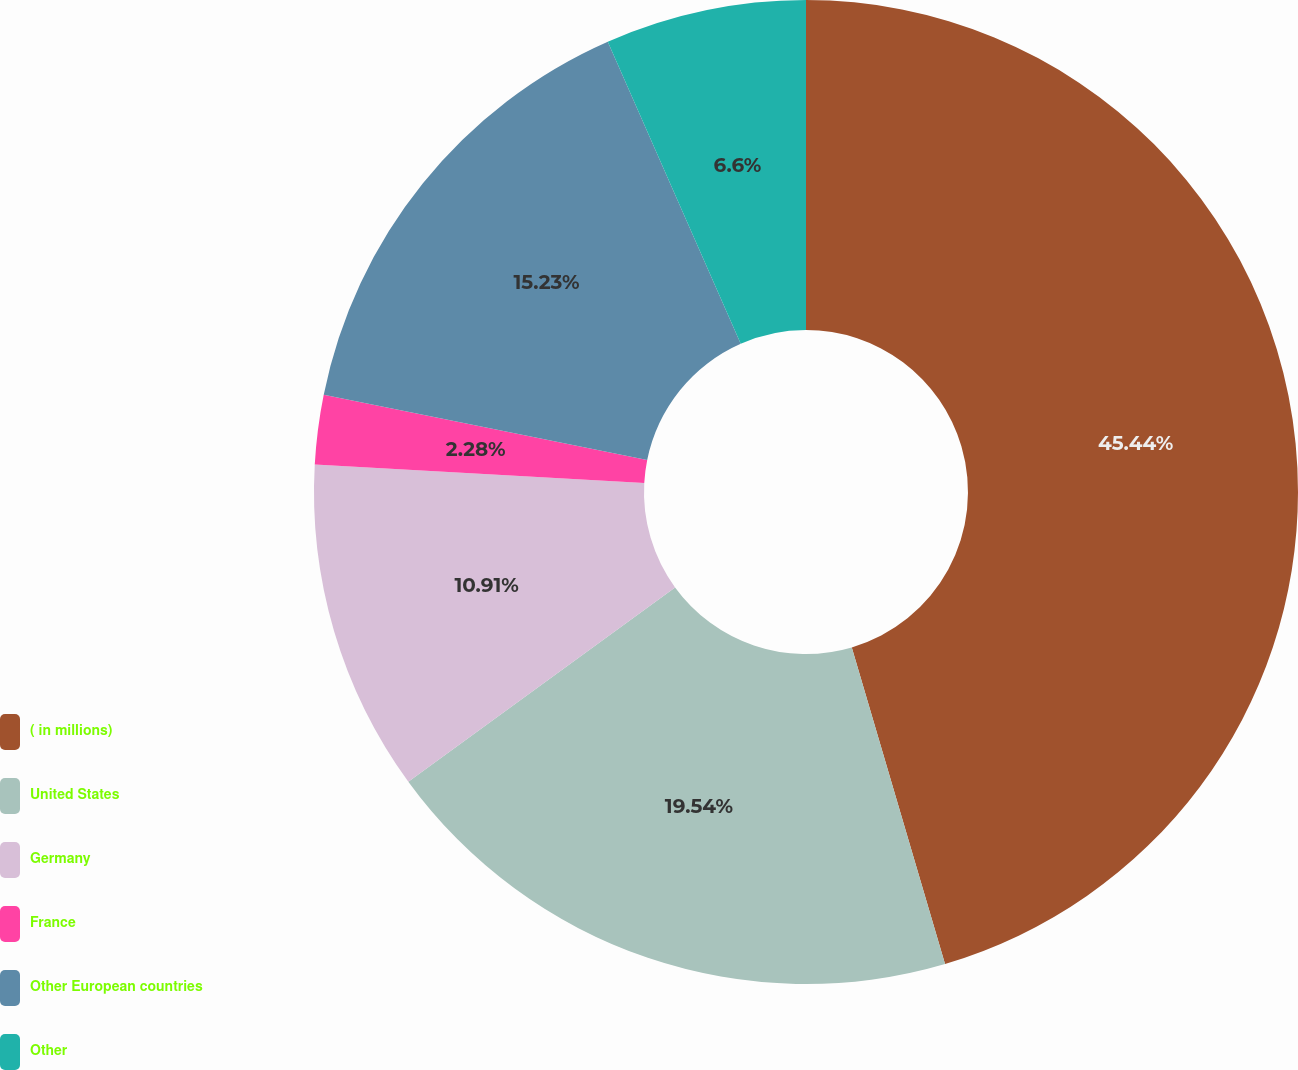Convert chart. <chart><loc_0><loc_0><loc_500><loc_500><pie_chart><fcel>( in millions)<fcel>United States<fcel>Germany<fcel>France<fcel>Other European countries<fcel>Other<nl><fcel>45.44%<fcel>19.54%<fcel>10.91%<fcel>2.28%<fcel>15.23%<fcel>6.6%<nl></chart> 